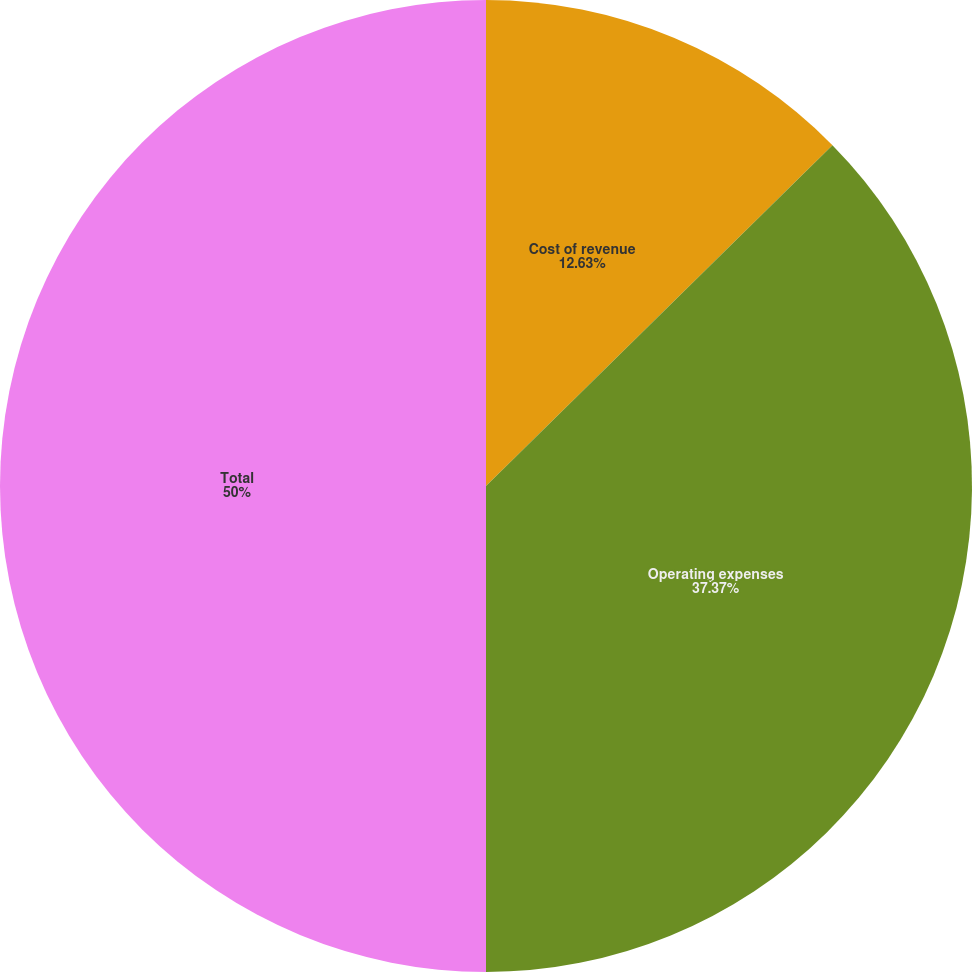Convert chart to OTSL. <chart><loc_0><loc_0><loc_500><loc_500><pie_chart><fcel>Cost of revenue<fcel>Operating expenses<fcel>Total<nl><fcel>12.63%<fcel>37.37%<fcel>50.0%<nl></chart> 